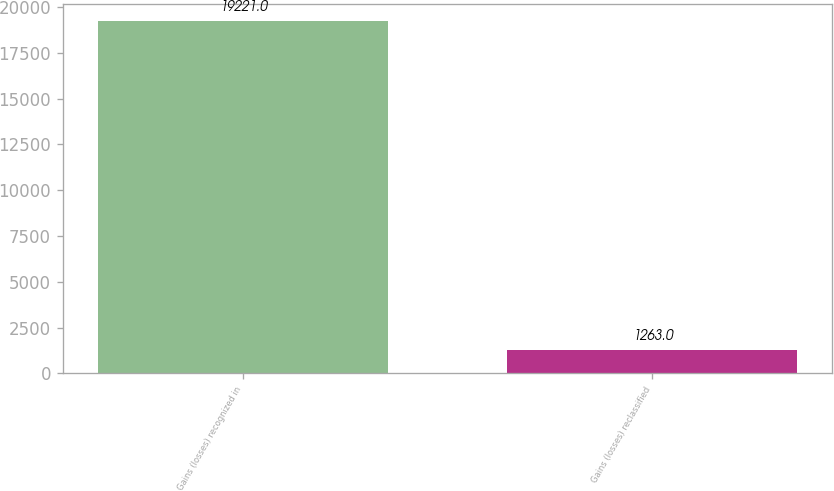Convert chart to OTSL. <chart><loc_0><loc_0><loc_500><loc_500><bar_chart><fcel>Gains (losses) recognized in<fcel>Gains (losses) reclassified<nl><fcel>19221<fcel>1263<nl></chart> 